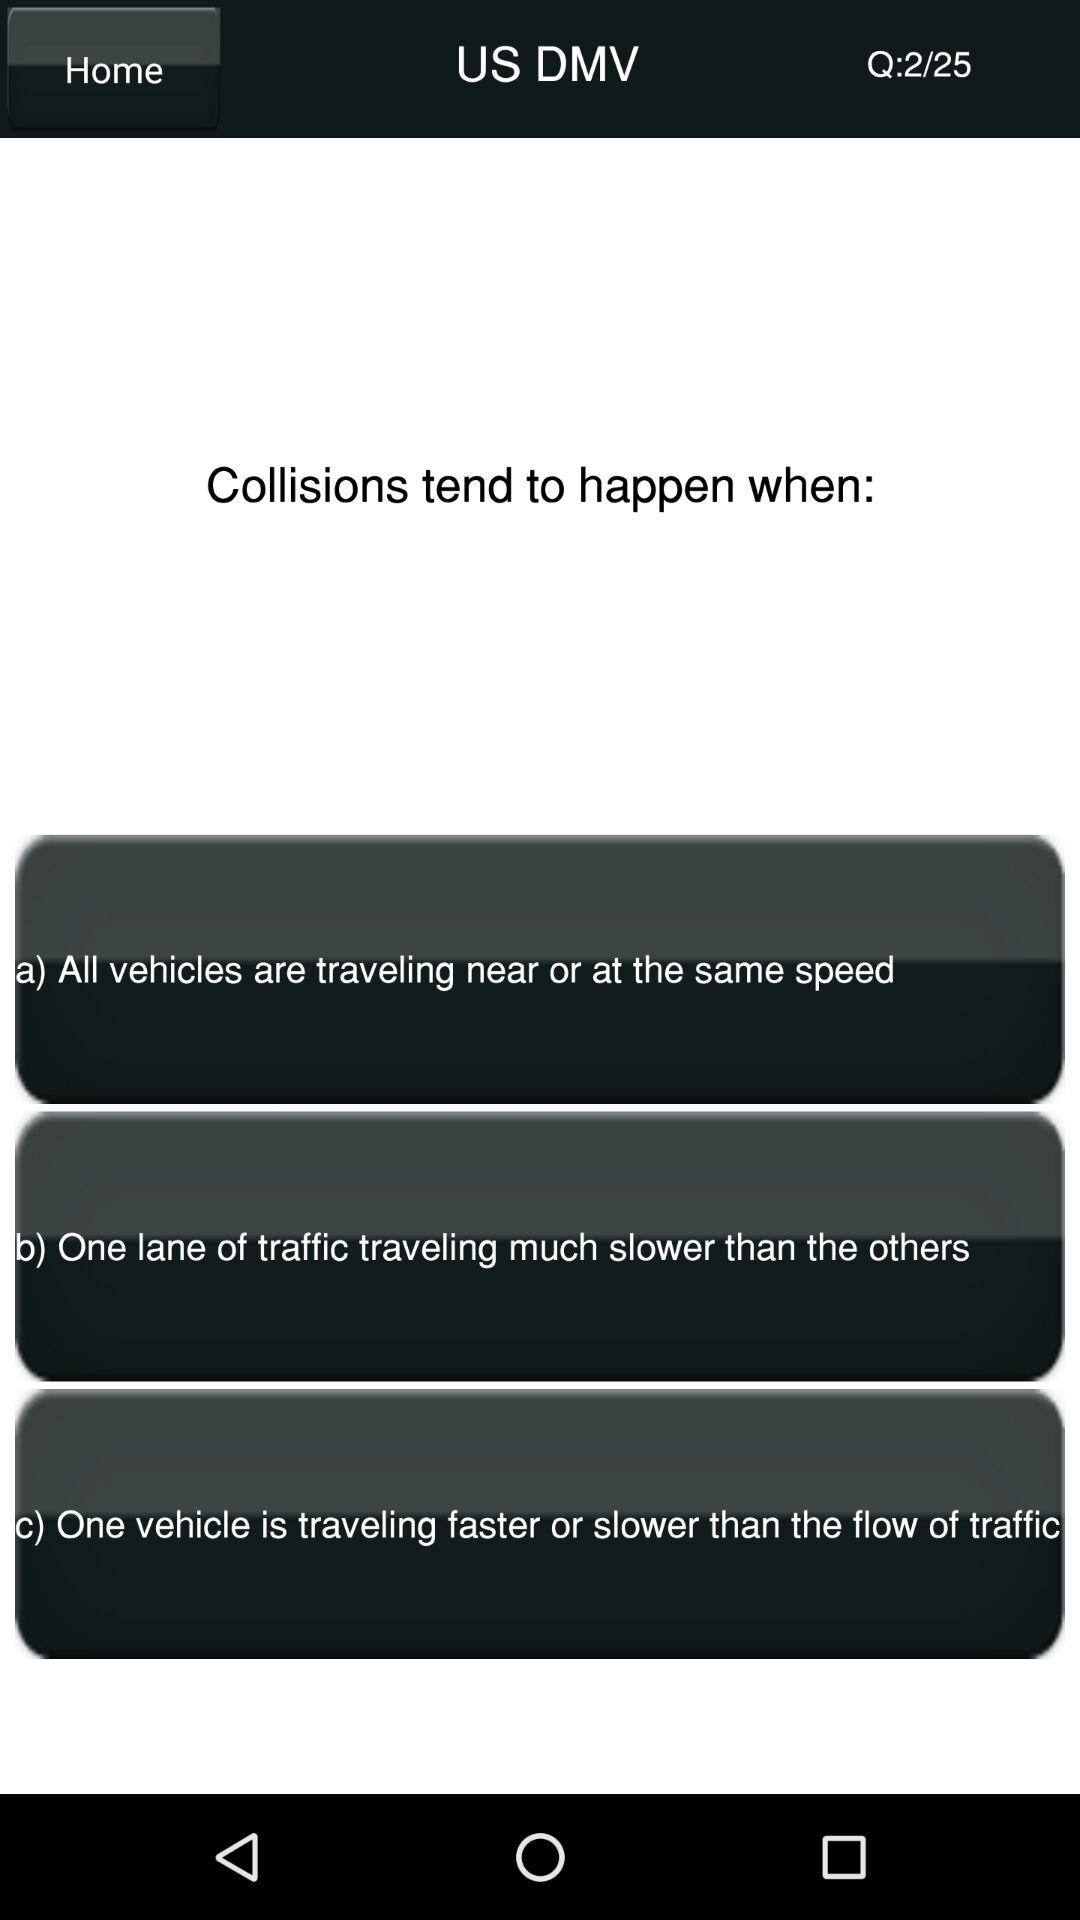What is the total number of questions? The total number of questions is 25. 